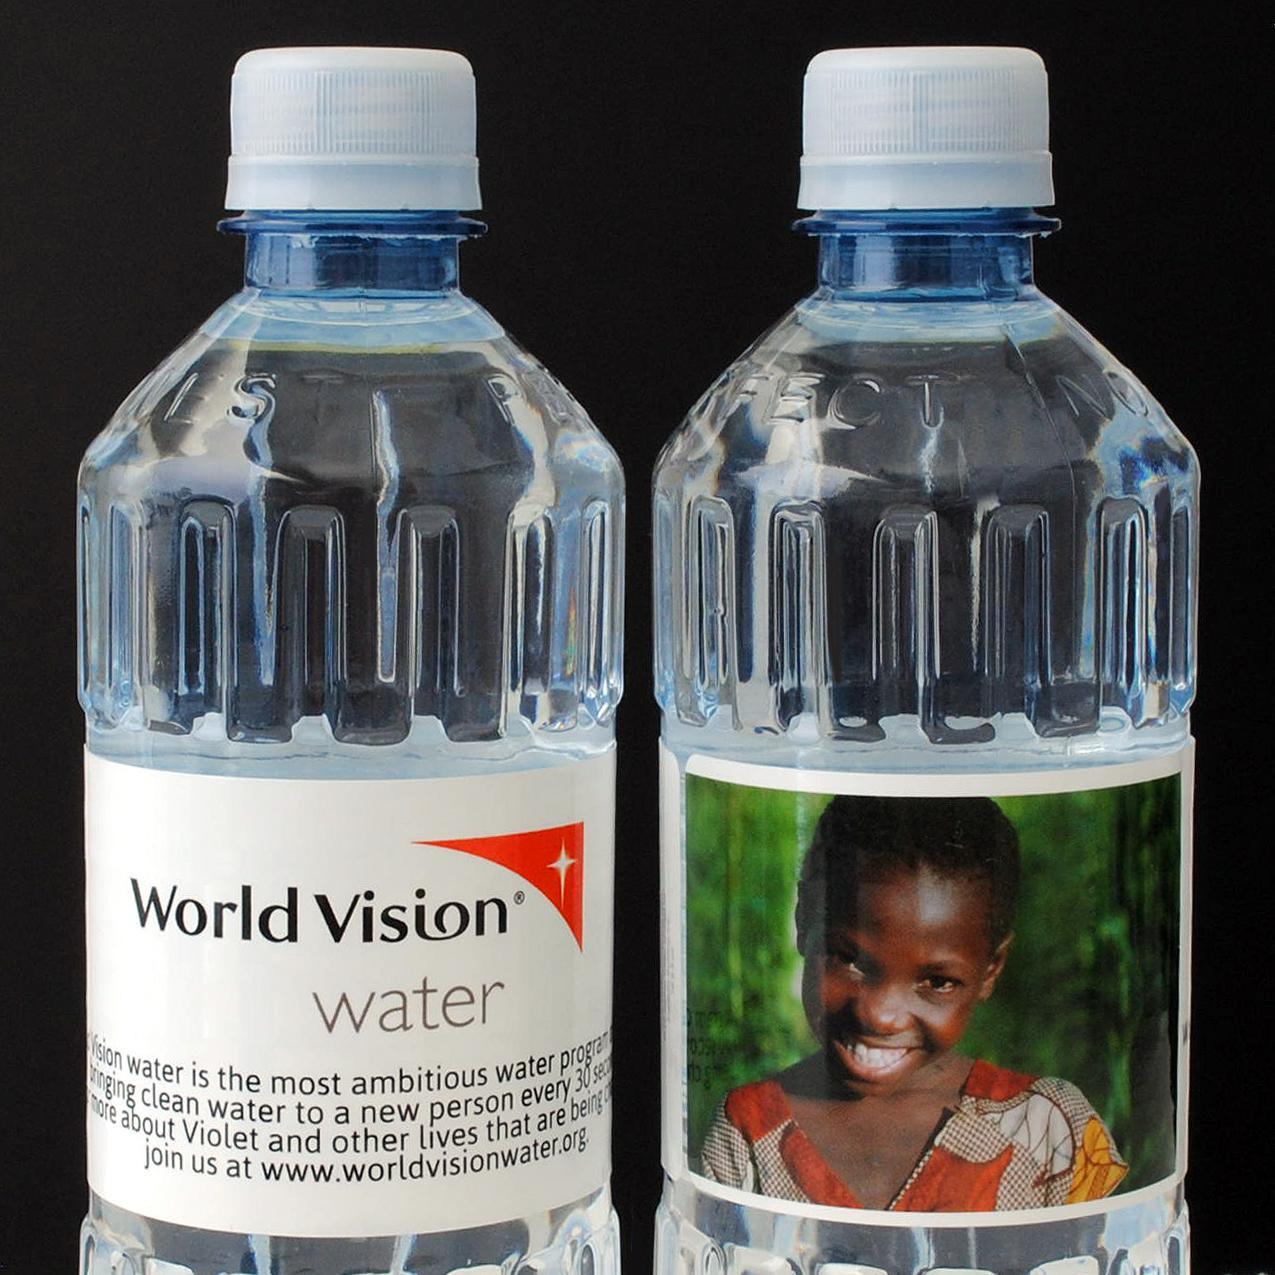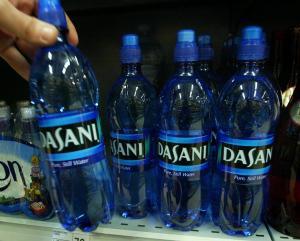The first image is the image on the left, the second image is the image on the right. Given the left and right images, does the statement "One image contains exactly two bottles displayed level and head-on, and the other image includes at least four identical bottles with identical labels." hold true? Answer yes or no. Yes. 